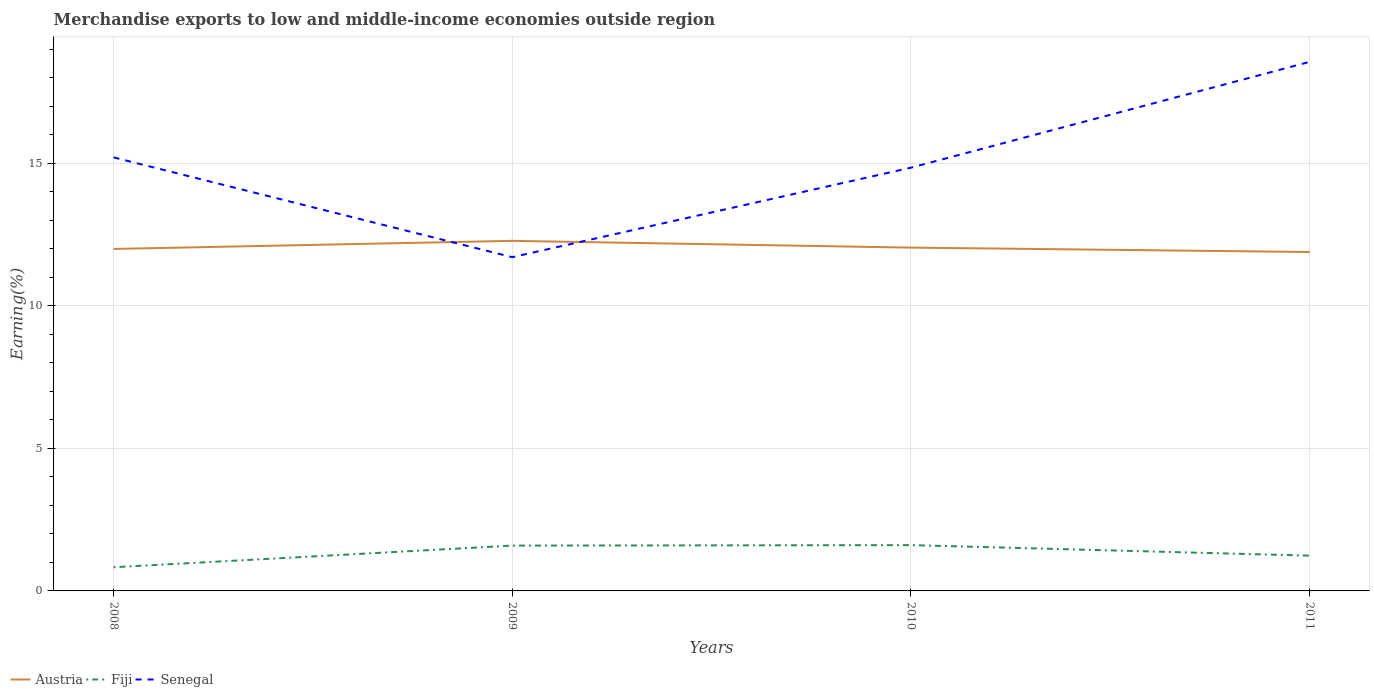Is the number of lines equal to the number of legend labels?
Your answer should be compact. Yes. Across all years, what is the maximum percentage of amount earned from merchandise exports in Fiji?
Give a very brief answer. 0.83. In which year was the percentage of amount earned from merchandise exports in Austria maximum?
Keep it short and to the point. 2011. What is the total percentage of amount earned from merchandise exports in Senegal in the graph?
Your response must be concise. -6.85. What is the difference between the highest and the second highest percentage of amount earned from merchandise exports in Austria?
Offer a terse response. 0.39. Is the percentage of amount earned from merchandise exports in Senegal strictly greater than the percentage of amount earned from merchandise exports in Fiji over the years?
Keep it short and to the point. No. What is the difference between two consecutive major ticks on the Y-axis?
Make the answer very short. 5. Are the values on the major ticks of Y-axis written in scientific E-notation?
Keep it short and to the point. No. Does the graph contain any zero values?
Your answer should be compact. No. How are the legend labels stacked?
Offer a terse response. Horizontal. What is the title of the graph?
Your answer should be compact. Merchandise exports to low and middle-income economies outside region. Does "Virgin Islands" appear as one of the legend labels in the graph?
Provide a succinct answer. No. What is the label or title of the X-axis?
Offer a very short reply. Years. What is the label or title of the Y-axis?
Offer a very short reply. Earning(%). What is the Earning(%) of Austria in 2008?
Offer a very short reply. 12. What is the Earning(%) in Fiji in 2008?
Give a very brief answer. 0.83. What is the Earning(%) of Senegal in 2008?
Keep it short and to the point. 15.21. What is the Earning(%) in Austria in 2009?
Keep it short and to the point. 12.28. What is the Earning(%) of Fiji in 2009?
Your response must be concise. 1.59. What is the Earning(%) in Senegal in 2009?
Keep it short and to the point. 11.71. What is the Earning(%) in Austria in 2010?
Ensure brevity in your answer.  12.04. What is the Earning(%) of Fiji in 2010?
Your answer should be very brief. 1.61. What is the Earning(%) in Senegal in 2010?
Offer a terse response. 14.85. What is the Earning(%) of Austria in 2011?
Offer a very short reply. 11.89. What is the Earning(%) in Fiji in 2011?
Offer a terse response. 1.24. What is the Earning(%) of Senegal in 2011?
Your answer should be very brief. 18.56. Across all years, what is the maximum Earning(%) in Austria?
Offer a terse response. 12.28. Across all years, what is the maximum Earning(%) of Fiji?
Offer a terse response. 1.61. Across all years, what is the maximum Earning(%) of Senegal?
Your answer should be very brief. 18.56. Across all years, what is the minimum Earning(%) in Austria?
Your answer should be compact. 11.89. Across all years, what is the minimum Earning(%) in Fiji?
Keep it short and to the point. 0.83. Across all years, what is the minimum Earning(%) of Senegal?
Your response must be concise. 11.71. What is the total Earning(%) in Austria in the graph?
Give a very brief answer. 48.21. What is the total Earning(%) in Fiji in the graph?
Your response must be concise. 5.26. What is the total Earning(%) of Senegal in the graph?
Keep it short and to the point. 60.33. What is the difference between the Earning(%) of Austria in 2008 and that in 2009?
Your answer should be compact. -0.28. What is the difference between the Earning(%) of Fiji in 2008 and that in 2009?
Make the answer very short. -0.76. What is the difference between the Earning(%) of Senegal in 2008 and that in 2009?
Ensure brevity in your answer.  3.5. What is the difference between the Earning(%) of Austria in 2008 and that in 2010?
Provide a succinct answer. -0.05. What is the difference between the Earning(%) of Fiji in 2008 and that in 2010?
Offer a very short reply. -0.78. What is the difference between the Earning(%) in Senegal in 2008 and that in 2010?
Your answer should be very brief. 0.36. What is the difference between the Earning(%) in Austria in 2008 and that in 2011?
Ensure brevity in your answer.  0.11. What is the difference between the Earning(%) in Fiji in 2008 and that in 2011?
Provide a succinct answer. -0.41. What is the difference between the Earning(%) of Senegal in 2008 and that in 2011?
Make the answer very short. -3.35. What is the difference between the Earning(%) of Austria in 2009 and that in 2010?
Your answer should be very brief. 0.24. What is the difference between the Earning(%) of Fiji in 2009 and that in 2010?
Offer a terse response. -0.02. What is the difference between the Earning(%) of Senegal in 2009 and that in 2010?
Offer a very short reply. -3.14. What is the difference between the Earning(%) of Austria in 2009 and that in 2011?
Give a very brief answer. 0.39. What is the difference between the Earning(%) in Fiji in 2009 and that in 2011?
Provide a succinct answer. 0.35. What is the difference between the Earning(%) of Senegal in 2009 and that in 2011?
Offer a very short reply. -6.85. What is the difference between the Earning(%) in Austria in 2010 and that in 2011?
Your response must be concise. 0.15. What is the difference between the Earning(%) of Fiji in 2010 and that in 2011?
Give a very brief answer. 0.37. What is the difference between the Earning(%) of Senegal in 2010 and that in 2011?
Your answer should be compact. -3.71. What is the difference between the Earning(%) in Austria in 2008 and the Earning(%) in Fiji in 2009?
Make the answer very short. 10.41. What is the difference between the Earning(%) in Austria in 2008 and the Earning(%) in Senegal in 2009?
Ensure brevity in your answer.  0.29. What is the difference between the Earning(%) in Fiji in 2008 and the Earning(%) in Senegal in 2009?
Offer a terse response. -10.88. What is the difference between the Earning(%) of Austria in 2008 and the Earning(%) of Fiji in 2010?
Provide a succinct answer. 10.39. What is the difference between the Earning(%) in Austria in 2008 and the Earning(%) in Senegal in 2010?
Your answer should be very brief. -2.85. What is the difference between the Earning(%) in Fiji in 2008 and the Earning(%) in Senegal in 2010?
Make the answer very short. -14.02. What is the difference between the Earning(%) in Austria in 2008 and the Earning(%) in Fiji in 2011?
Provide a short and direct response. 10.76. What is the difference between the Earning(%) of Austria in 2008 and the Earning(%) of Senegal in 2011?
Offer a terse response. -6.56. What is the difference between the Earning(%) of Fiji in 2008 and the Earning(%) of Senegal in 2011?
Provide a short and direct response. -17.73. What is the difference between the Earning(%) in Austria in 2009 and the Earning(%) in Fiji in 2010?
Offer a terse response. 10.68. What is the difference between the Earning(%) of Austria in 2009 and the Earning(%) of Senegal in 2010?
Your answer should be very brief. -2.57. What is the difference between the Earning(%) in Fiji in 2009 and the Earning(%) in Senegal in 2010?
Your answer should be very brief. -13.26. What is the difference between the Earning(%) in Austria in 2009 and the Earning(%) in Fiji in 2011?
Give a very brief answer. 11.04. What is the difference between the Earning(%) in Austria in 2009 and the Earning(%) in Senegal in 2011?
Offer a terse response. -6.28. What is the difference between the Earning(%) in Fiji in 2009 and the Earning(%) in Senegal in 2011?
Provide a short and direct response. -16.97. What is the difference between the Earning(%) of Austria in 2010 and the Earning(%) of Fiji in 2011?
Offer a very short reply. 10.81. What is the difference between the Earning(%) in Austria in 2010 and the Earning(%) in Senegal in 2011?
Keep it short and to the point. -6.52. What is the difference between the Earning(%) of Fiji in 2010 and the Earning(%) of Senegal in 2011?
Make the answer very short. -16.96. What is the average Earning(%) of Austria per year?
Offer a very short reply. 12.05. What is the average Earning(%) of Fiji per year?
Your answer should be very brief. 1.32. What is the average Earning(%) in Senegal per year?
Provide a short and direct response. 15.08. In the year 2008, what is the difference between the Earning(%) in Austria and Earning(%) in Fiji?
Your answer should be compact. 11.17. In the year 2008, what is the difference between the Earning(%) in Austria and Earning(%) in Senegal?
Your response must be concise. -3.21. In the year 2008, what is the difference between the Earning(%) in Fiji and Earning(%) in Senegal?
Your answer should be compact. -14.38. In the year 2009, what is the difference between the Earning(%) of Austria and Earning(%) of Fiji?
Provide a short and direct response. 10.69. In the year 2009, what is the difference between the Earning(%) of Austria and Earning(%) of Senegal?
Make the answer very short. 0.57. In the year 2009, what is the difference between the Earning(%) in Fiji and Earning(%) in Senegal?
Ensure brevity in your answer.  -10.12. In the year 2010, what is the difference between the Earning(%) in Austria and Earning(%) in Fiji?
Your response must be concise. 10.44. In the year 2010, what is the difference between the Earning(%) of Austria and Earning(%) of Senegal?
Your answer should be very brief. -2.8. In the year 2010, what is the difference between the Earning(%) in Fiji and Earning(%) in Senegal?
Offer a very short reply. -13.24. In the year 2011, what is the difference between the Earning(%) of Austria and Earning(%) of Fiji?
Your answer should be very brief. 10.65. In the year 2011, what is the difference between the Earning(%) of Austria and Earning(%) of Senegal?
Give a very brief answer. -6.67. In the year 2011, what is the difference between the Earning(%) in Fiji and Earning(%) in Senegal?
Offer a very short reply. -17.32. What is the ratio of the Earning(%) in Austria in 2008 to that in 2009?
Your answer should be compact. 0.98. What is the ratio of the Earning(%) in Fiji in 2008 to that in 2009?
Your response must be concise. 0.52. What is the ratio of the Earning(%) in Senegal in 2008 to that in 2009?
Ensure brevity in your answer.  1.3. What is the ratio of the Earning(%) of Fiji in 2008 to that in 2010?
Your answer should be very brief. 0.52. What is the ratio of the Earning(%) of Senegal in 2008 to that in 2010?
Your answer should be compact. 1.02. What is the ratio of the Earning(%) of Austria in 2008 to that in 2011?
Provide a short and direct response. 1.01. What is the ratio of the Earning(%) of Fiji in 2008 to that in 2011?
Offer a very short reply. 0.67. What is the ratio of the Earning(%) of Senegal in 2008 to that in 2011?
Ensure brevity in your answer.  0.82. What is the ratio of the Earning(%) of Austria in 2009 to that in 2010?
Ensure brevity in your answer.  1.02. What is the ratio of the Earning(%) in Senegal in 2009 to that in 2010?
Make the answer very short. 0.79. What is the ratio of the Earning(%) in Austria in 2009 to that in 2011?
Offer a very short reply. 1.03. What is the ratio of the Earning(%) in Fiji in 2009 to that in 2011?
Your response must be concise. 1.29. What is the ratio of the Earning(%) of Senegal in 2009 to that in 2011?
Your answer should be compact. 0.63. What is the ratio of the Earning(%) in Austria in 2010 to that in 2011?
Your answer should be compact. 1.01. What is the ratio of the Earning(%) of Fiji in 2010 to that in 2011?
Your answer should be compact. 1.3. What is the difference between the highest and the second highest Earning(%) of Austria?
Offer a terse response. 0.24. What is the difference between the highest and the second highest Earning(%) in Fiji?
Offer a terse response. 0.02. What is the difference between the highest and the second highest Earning(%) of Senegal?
Your response must be concise. 3.35. What is the difference between the highest and the lowest Earning(%) of Austria?
Ensure brevity in your answer.  0.39. What is the difference between the highest and the lowest Earning(%) in Fiji?
Give a very brief answer. 0.78. What is the difference between the highest and the lowest Earning(%) in Senegal?
Offer a very short reply. 6.85. 